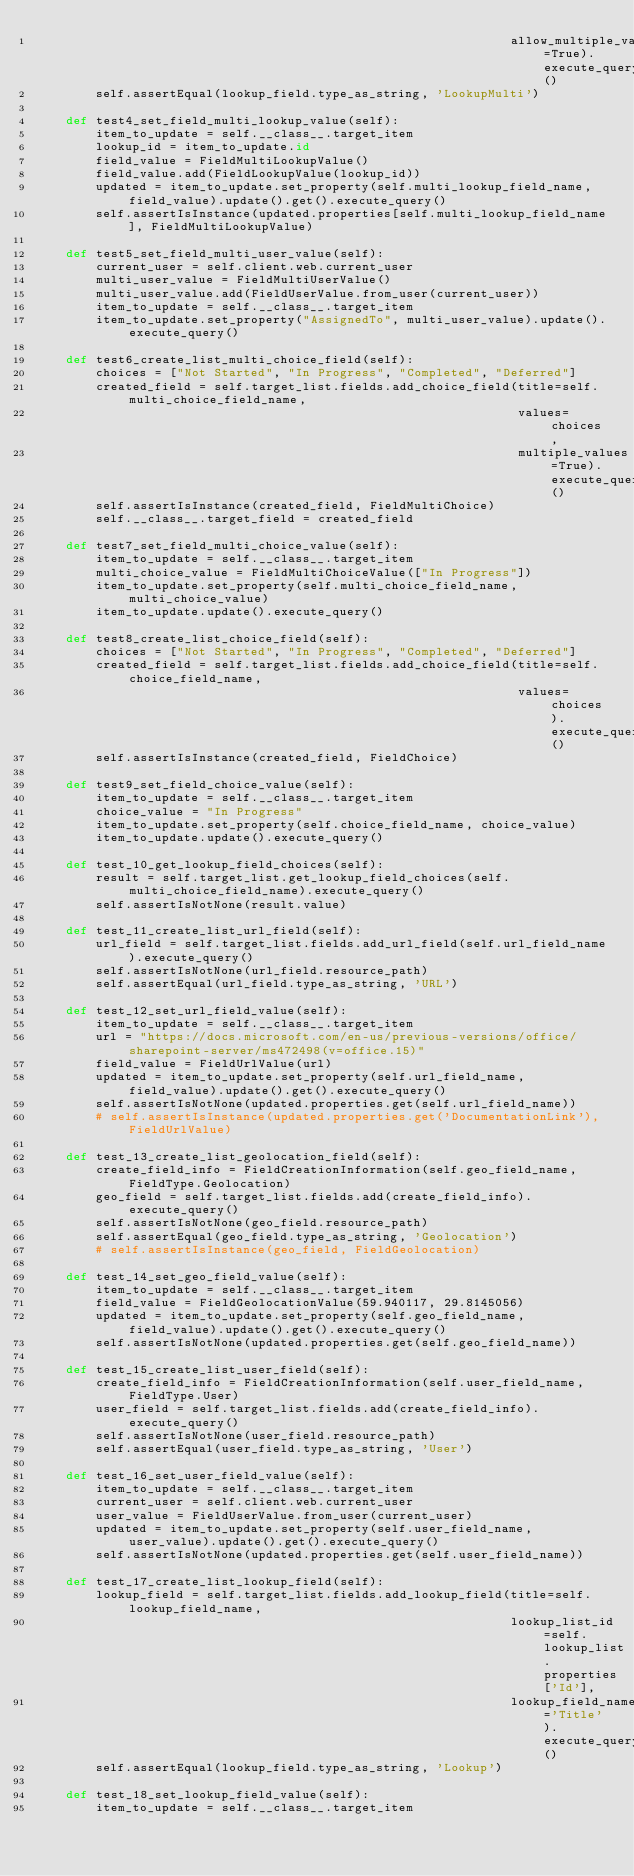<code> <loc_0><loc_0><loc_500><loc_500><_Python_>                                                                allow_multiple_values=True).execute_query()
        self.assertEqual(lookup_field.type_as_string, 'LookupMulti')

    def test4_set_field_multi_lookup_value(self):
        item_to_update = self.__class__.target_item
        lookup_id = item_to_update.id
        field_value = FieldMultiLookupValue()
        field_value.add(FieldLookupValue(lookup_id))
        updated = item_to_update.set_property(self.multi_lookup_field_name, field_value).update().get().execute_query()
        self.assertIsInstance(updated.properties[self.multi_lookup_field_name], FieldMultiLookupValue)

    def test5_set_field_multi_user_value(self):
        current_user = self.client.web.current_user
        multi_user_value = FieldMultiUserValue()
        multi_user_value.add(FieldUserValue.from_user(current_user))
        item_to_update = self.__class__.target_item
        item_to_update.set_property("AssignedTo", multi_user_value).update().execute_query()

    def test6_create_list_multi_choice_field(self):
        choices = ["Not Started", "In Progress", "Completed", "Deferred"]
        created_field = self.target_list.fields.add_choice_field(title=self.multi_choice_field_name,
                                                                 values=choices,
                                                                 multiple_values=True).execute_query()
        self.assertIsInstance(created_field, FieldMultiChoice)
        self.__class__.target_field = created_field

    def test7_set_field_multi_choice_value(self):
        item_to_update = self.__class__.target_item
        multi_choice_value = FieldMultiChoiceValue(["In Progress"])
        item_to_update.set_property(self.multi_choice_field_name, multi_choice_value)
        item_to_update.update().execute_query()

    def test8_create_list_choice_field(self):
        choices = ["Not Started", "In Progress", "Completed", "Deferred"]
        created_field = self.target_list.fields.add_choice_field(title=self.choice_field_name,
                                                                 values=choices).execute_query()
        self.assertIsInstance(created_field, FieldChoice)

    def test9_set_field_choice_value(self):
        item_to_update = self.__class__.target_item
        choice_value = "In Progress"
        item_to_update.set_property(self.choice_field_name, choice_value)
        item_to_update.update().execute_query()

    def test_10_get_lookup_field_choices(self):
        result = self.target_list.get_lookup_field_choices(self.multi_choice_field_name).execute_query()
        self.assertIsNotNone(result.value)

    def test_11_create_list_url_field(self):
        url_field = self.target_list.fields.add_url_field(self.url_field_name).execute_query()
        self.assertIsNotNone(url_field.resource_path)
        self.assertEqual(url_field.type_as_string, 'URL')

    def test_12_set_url_field_value(self):
        item_to_update = self.__class__.target_item
        url = "https://docs.microsoft.com/en-us/previous-versions/office/sharepoint-server/ms472498(v=office.15)"
        field_value = FieldUrlValue(url)
        updated = item_to_update.set_property(self.url_field_name, field_value).update().get().execute_query()
        self.assertIsNotNone(updated.properties.get(self.url_field_name))
        # self.assertIsInstance(updated.properties.get('DocumentationLink'), FieldUrlValue)

    def test_13_create_list_geolocation_field(self):
        create_field_info = FieldCreationInformation(self.geo_field_name, FieldType.Geolocation)
        geo_field = self.target_list.fields.add(create_field_info).execute_query()
        self.assertIsNotNone(geo_field.resource_path)
        self.assertEqual(geo_field.type_as_string, 'Geolocation')
        # self.assertIsInstance(geo_field, FieldGeolocation)

    def test_14_set_geo_field_value(self):
        item_to_update = self.__class__.target_item
        field_value = FieldGeolocationValue(59.940117, 29.8145056)
        updated = item_to_update.set_property(self.geo_field_name, field_value).update().get().execute_query()
        self.assertIsNotNone(updated.properties.get(self.geo_field_name))

    def test_15_create_list_user_field(self):
        create_field_info = FieldCreationInformation(self.user_field_name, FieldType.User)
        user_field = self.target_list.fields.add(create_field_info).execute_query()
        self.assertIsNotNone(user_field.resource_path)
        self.assertEqual(user_field.type_as_string, 'User')

    def test_16_set_user_field_value(self):
        item_to_update = self.__class__.target_item
        current_user = self.client.web.current_user
        user_value = FieldUserValue.from_user(current_user)
        updated = item_to_update.set_property(self.user_field_name, user_value).update().get().execute_query()
        self.assertIsNotNone(updated.properties.get(self.user_field_name))

    def test_17_create_list_lookup_field(self):
        lookup_field = self.target_list.fields.add_lookup_field(title=self.lookup_field_name,
                                                                lookup_list_id=self.lookup_list.properties['Id'],
                                                                lookup_field_name='Title').execute_query()
        self.assertEqual(lookup_field.type_as_string, 'Lookup')

    def test_18_set_lookup_field_value(self):
        item_to_update = self.__class__.target_item</code> 